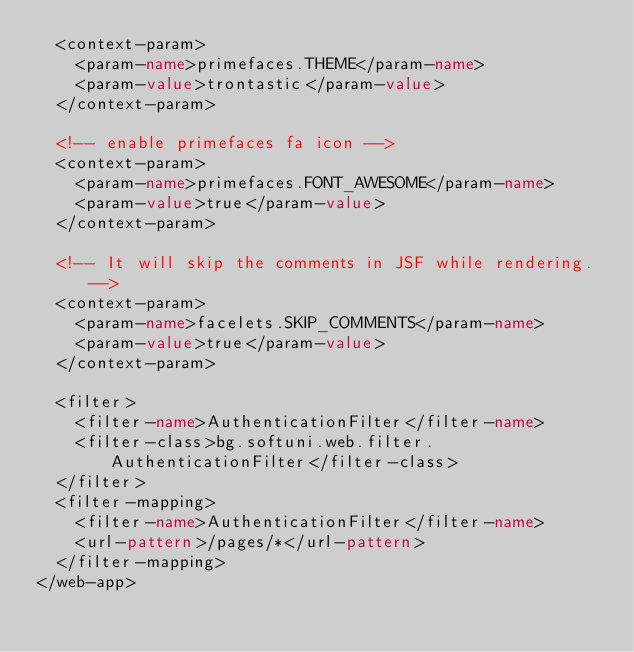Convert code to text. <code><loc_0><loc_0><loc_500><loc_500><_XML_>	<context-param>
		<param-name>primefaces.THEME</param-name>
		<param-value>trontastic</param-value>
	</context-param>
	
	<!-- enable primefaces fa icon -->
	<context-param>
		<param-name>primefaces.FONT_AWESOME</param-name>
		<param-value>true</param-value>
	</context-param>

	<!-- It will skip the comments in JSF while rendering. -->
	<context-param>
		<param-name>facelets.SKIP_COMMENTS</param-name>
		<param-value>true</param-value>
	</context-param>

	<filter>
		<filter-name>AuthenticationFilter</filter-name>
		<filter-class>bg.softuni.web.filter.AuthenticationFilter</filter-class>
	</filter>
	<filter-mapping>
		<filter-name>AuthenticationFilter</filter-name>
		<url-pattern>/pages/*</url-pattern>
	</filter-mapping>
</web-app></code> 